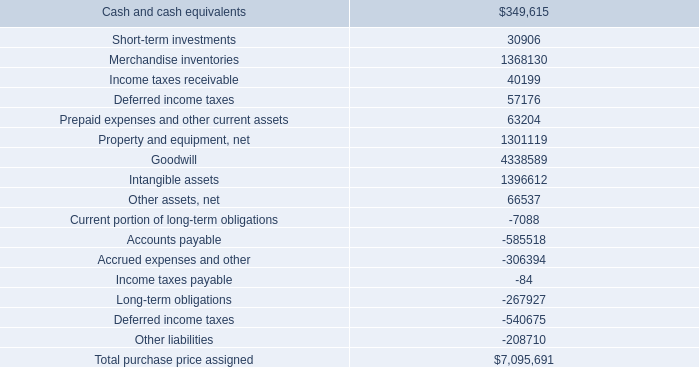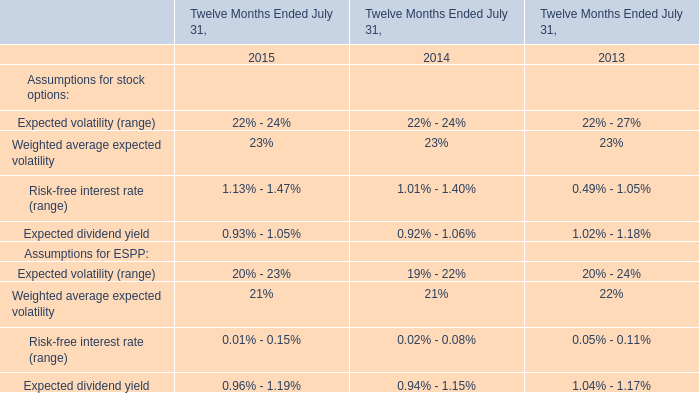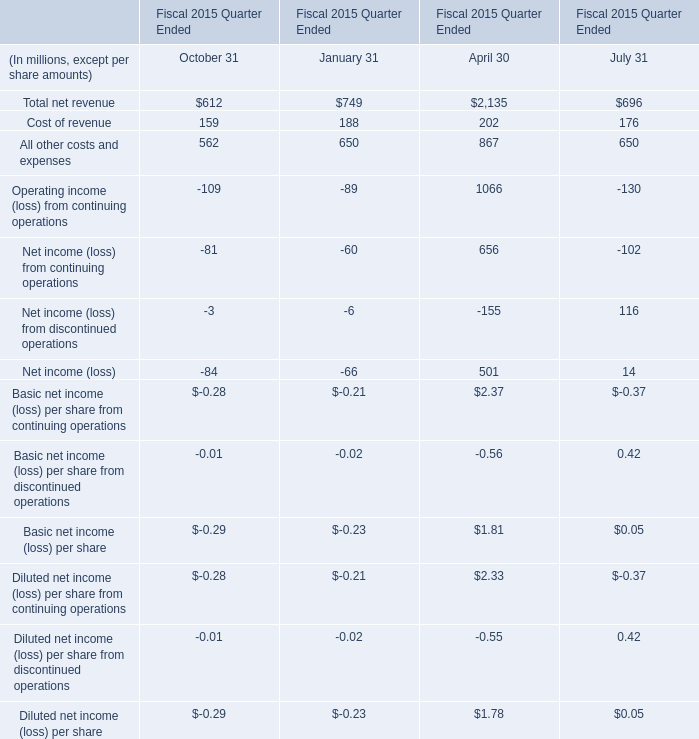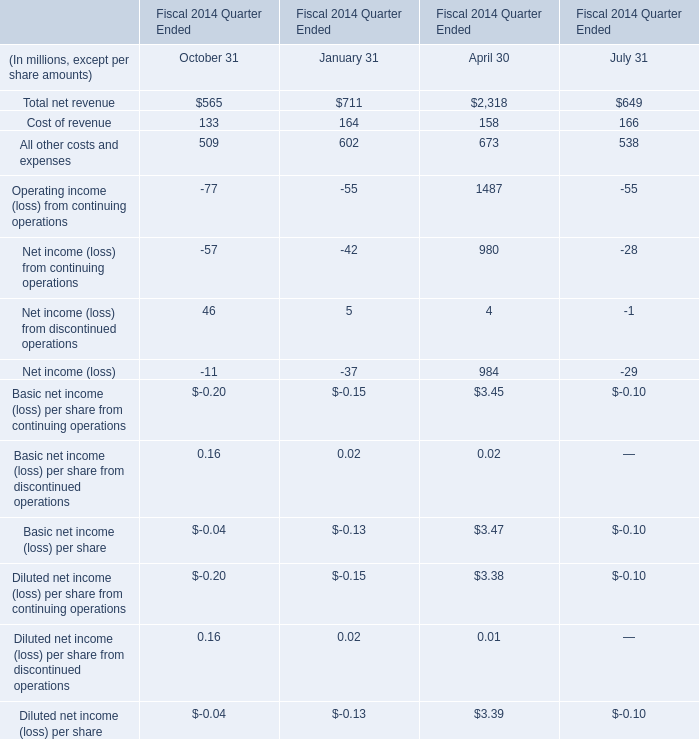What is the ratio of all October 31 that are smaller than -80 to the sum of October 31 in 2015? 
Computations: ((-81 - 109) / ((((((-0.29 - 0.29) - 84) - 109) + 562) + 159) + 612))
Answer: -0.16675. 